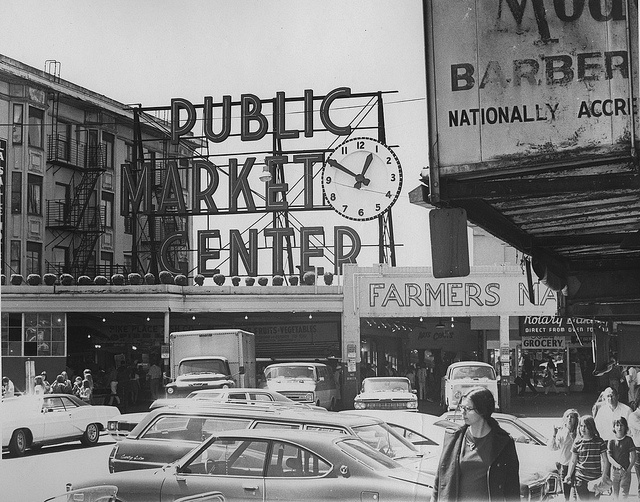Describe the objects in this image and their specific colors. I can see car in lightgray, darkgray, gray, and black tones, car in lightgray, darkgray, gray, and black tones, people in lightgray, black, gray, and darkgray tones, people in lightgray, black, gray, and darkgray tones, and truck in lightgray, darkgray, gray, and black tones in this image. 